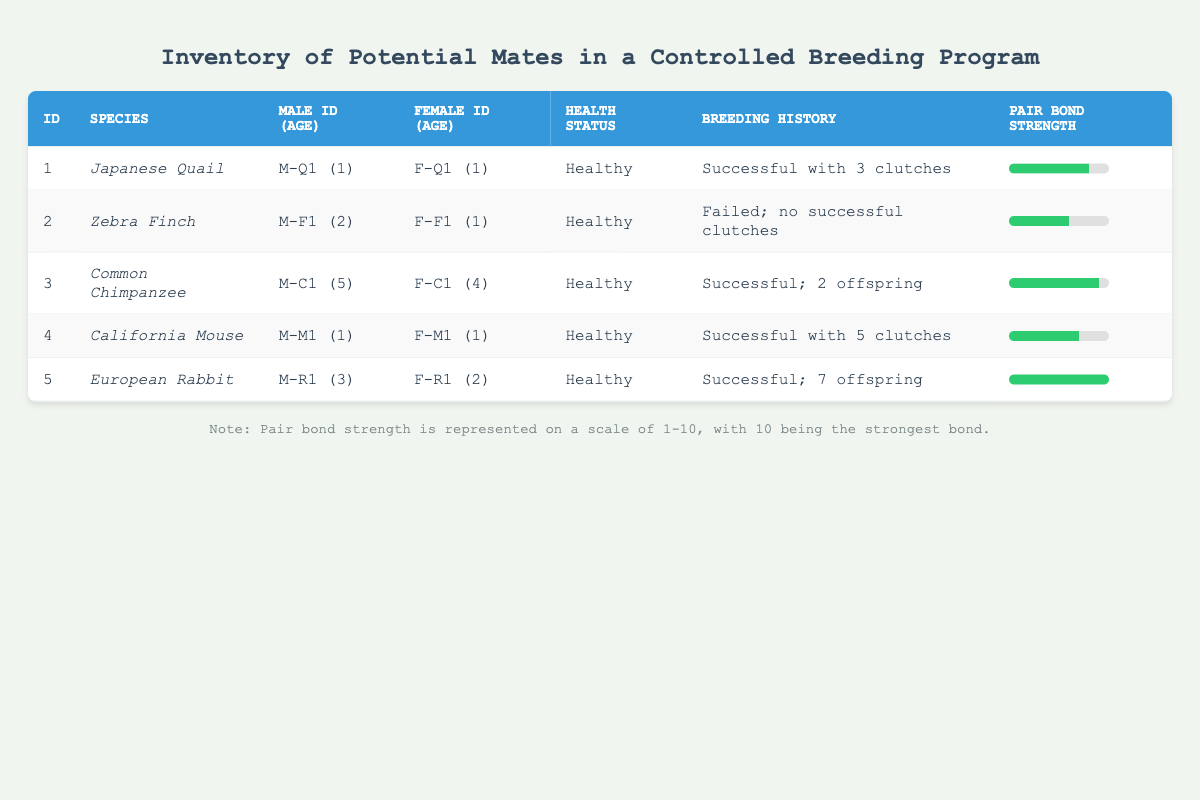What is the pair bond strength of the European Rabbit? The table shows the pair bond strength for the European Rabbit is indicated under the "Pair Bond Strength" column. The European Rabbit, identified as entry 5, has a pair bond strength of 10.
Answer: 10 Which species has the highest pair bond strength? To find the species with the highest pair bond strength, we can look at the pair bond strength values across the table. The European Rabbit has the highest strength value of 10.
Answer: European Rabbit How many successful breeding histories are recorded for the California Mouse? The health status and breeding history for the California Mouse are indicated in the respective columns. The breeding history shows it has had a successful history with 5 clutches.
Answer: 5 clutches True or False: The Zebra Finch is the only species recorded as having failed to have successful clutches. Based on the data in the breeding history column, the Zebra Finch is noted to have "Failed; no successful clutches." No other species are indicated as having failed. Thus, the statement is true.
Answer: True What is the average age of the males in the inventory? To calculate the average age of the males, sum their ages: (1 + 2 + 5 + 1 + 3) = 12. There are 5 males, so the average age is 12/5 = 2.4.
Answer: 2.4 Which species has a successful breeding history with the most offspring? By examining the breeding history column, the European Rabbit has a successful record with 7 offspring, which indicates it is the species with the most recorded offspring.
Answer: European Rabbit Is there any species with a pair bond strength of less than 7? Looking at the pair bond strength column, the Zebra Finch has a strength of 6, which is less than 7. Therefore, at least one species meets the criteria.
Answer: Yes What is the total number of successful clutches recorded for the Japanese Quail and California Mouse combined? From the breeding history column, the Japanese Quail has 3 clutches and the California Mouse has 5 clutches. Adding these together gives 3 + 5 = 8 successful clutches.
Answer: 8 clutches 